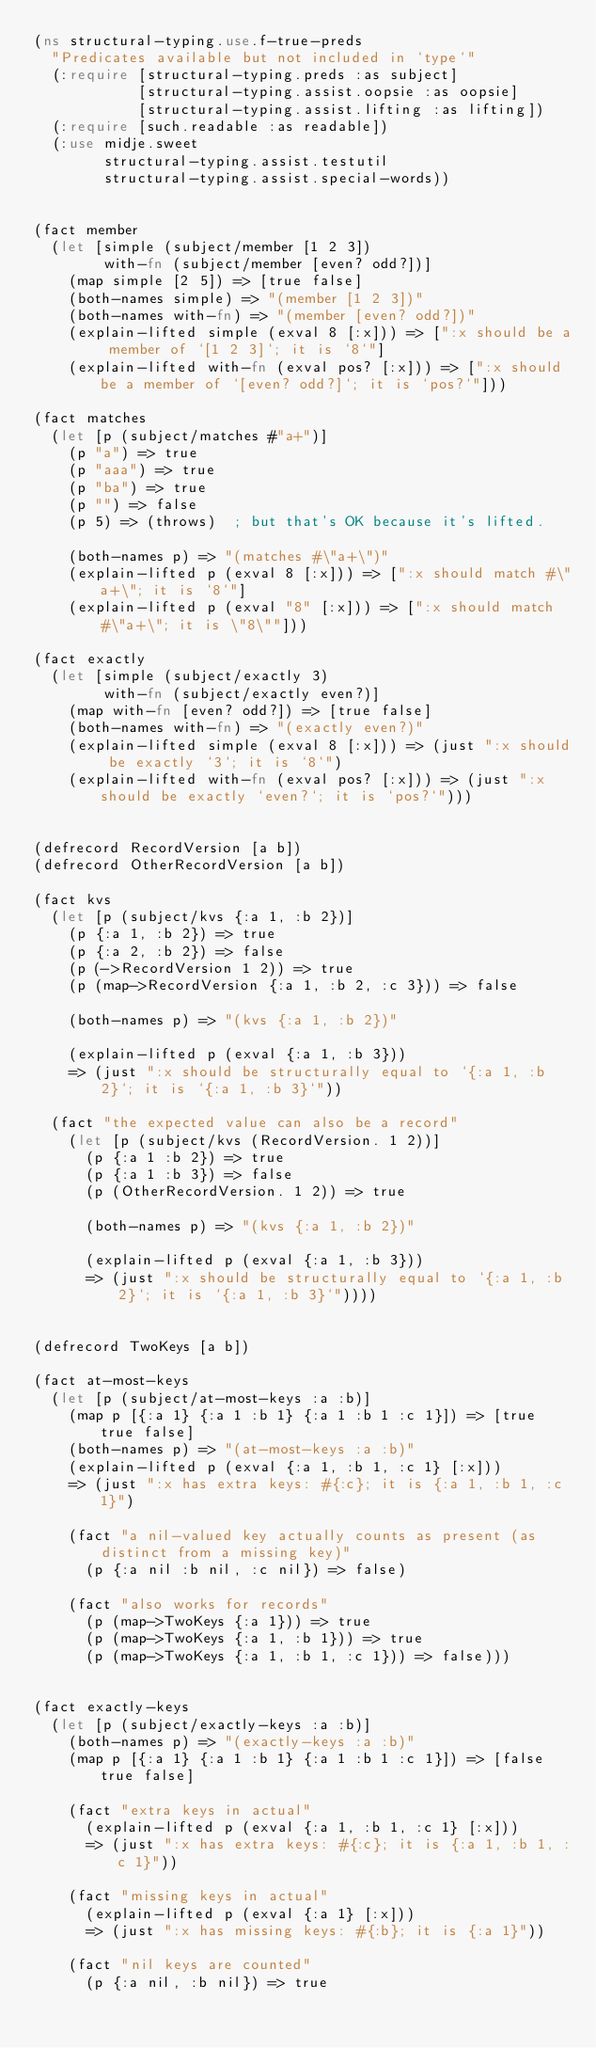<code> <loc_0><loc_0><loc_500><loc_500><_Clojure_>(ns structural-typing.use.f-true-preds
  "Predicates available but not included in `type`"
  (:require [structural-typing.preds :as subject]
            [structural-typing.assist.oopsie :as oopsie]
            [structural-typing.assist.lifting :as lifting])
  (:require [such.readable :as readable])
  (:use midje.sweet
        structural-typing.assist.testutil
        structural-typing.assist.special-words))


(fact member
  (let [simple (subject/member [1 2 3])
        with-fn (subject/member [even? odd?])]
    (map simple [2 5]) => [true false]
    (both-names simple) => "(member [1 2 3])"
    (both-names with-fn) => "(member [even? odd?])"
    (explain-lifted simple (exval 8 [:x])) => [":x should be a member of `[1 2 3]`; it is `8`"]
    (explain-lifted with-fn (exval pos? [:x])) => [":x should be a member of `[even? odd?]`; it is `pos?`"]))

(fact matches
  (let [p (subject/matches #"a+")]
    (p "a") => true
    (p "aaa") => true
    (p "ba") => true
    (p "") => false
    (p 5) => (throws)  ; but that's OK because it's lifted.

    (both-names p) => "(matches #\"a+\")"
    (explain-lifted p (exval 8 [:x])) => [":x should match #\"a+\"; it is `8`"]
    (explain-lifted p (exval "8" [:x])) => [":x should match #\"a+\"; it is \"8\""]))

(fact exactly
  (let [simple (subject/exactly 3)
        with-fn (subject/exactly even?)]
    (map with-fn [even? odd?]) => [true false]
    (both-names with-fn) => "(exactly even?)"
    (explain-lifted simple (exval 8 [:x])) => (just ":x should be exactly `3`; it is `8`")
    (explain-lifted with-fn (exval pos? [:x])) => (just ":x should be exactly `even?`; it is `pos?`")))


(defrecord RecordVersion [a b])
(defrecord OtherRecordVersion [a b])

(fact kvs
  (let [p (subject/kvs {:a 1, :b 2})]
    (p {:a 1, :b 2}) => true
    (p {:a 2, :b 2}) => false
    (p (->RecordVersion 1 2)) => true
    (p (map->RecordVersion {:a 1, :b 2, :c 3})) => false

    (both-names p) => "(kvs {:a 1, :b 2})"

    (explain-lifted p (exval {:a 1, :b 3}))
    => (just ":x should be structurally equal to `{:a 1, :b 2}`; it is `{:a 1, :b 3}`"))

  (fact "the expected value can also be a record"
    (let [p (subject/kvs (RecordVersion. 1 2))]
      (p {:a 1 :b 2}) => true
      (p {:a 1 :b 3}) => false
      (p (OtherRecordVersion. 1 2)) => true

      (both-names p) => "(kvs {:a 1, :b 2})"

      (explain-lifted p (exval {:a 1, :b 3}))
      => (just ":x should be structurally equal to `{:a 1, :b 2}`; it is `{:a 1, :b 3}`"))))


(defrecord TwoKeys [a b])

(fact at-most-keys
  (let [p (subject/at-most-keys :a :b)]
    (map p [{:a 1} {:a 1 :b 1} {:a 1 :b 1 :c 1}]) => [true true false]
    (both-names p) => "(at-most-keys :a :b)"
    (explain-lifted p (exval {:a 1, :b 1, :c 1} [:x]))
    => (just ":x has extra keys: #{:c}; it is {:a 1, :b 1, :c 1}")

    (fact "a nil-valued key actually counts as present (as distinct from a missing key)"
      (p {:a nil :b nil, :c nil}) => false)

    (fact "also works for records"
      (p (map->TwoKeys {:a 1})) => true
      (p (map->TwoKeys {:a 1, :b 1})) => true
      (p (map->TwoKeys {:a 1, :b 1, :c 1})) => false)))


(fact exactly-keys
  (let [p (subject/exactly-keys :a :b)]
    (both-names p) => "(exactly-keys :a :b)"
    (map p [{:a 1} {:a 1 :b 1} {:a 1 :b 1 :c 1}]) => [false true false]

    (fact "extra keys in actual"
      (explain-lifted p (exval {:a 1, :b 1, :c 1} [:x]))
      => (just ":x has extra keys: #{:c}; it is {:a 1, :b 1, :c 1}"))
  
    (fact "missing keys in actual"
      (explain-lifted p (exval {:a 1} [:x]))
      => (just ":x has missing keys: #{:b}; it is {:a 1}"))

    (fact "nil keys are counted"
      (p {:a nil, :b nil}) => true</code> 